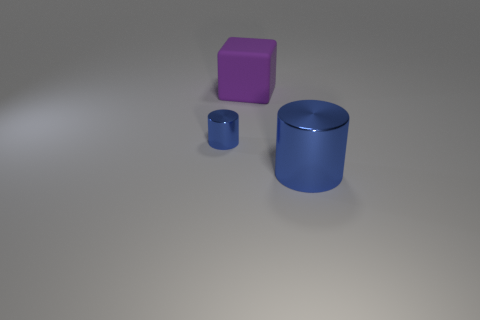Does the cylinder behind the big blue cylinder have the same size as the cylinder that is right of the big purple cube?
Provide a short and direct response. No. There is a object that is behind the big blue thing and in front of the large purple matte block; what material is it made of?
Offer a terse response. Metal. Is there anything else that is the same color as the small shiny cylinder?
Make the answer very short. Yes. Are there fewer matte things on the left side of the big purple matte object than purple matte blocks?
Provide a succinct answer. Yes. Are there more red metal spheres than purple cubes?
Your answer should be compact. No. Is there a tiny blue shiny cylinder that is in front of the large thing to the left of the metallic cylinder in front of the tiny blue thing?
Your response must be concise. Yes. How many other objects are the same size as the block?
Make the answer very short. 1. There is a large blue shiny cylinder; are there any cylinders to the left of it?
Ensure brevity in your answer.  Yes. Is the color of the small thing the same as the large object in front of the tiny blue metallic thing?
Offer a terse response. Yes. There is a cylinder that is behind the blue cylinder right of the blue cylinder that is on the left side of the big block; what color is it?
Your response must be concise. Blue. 